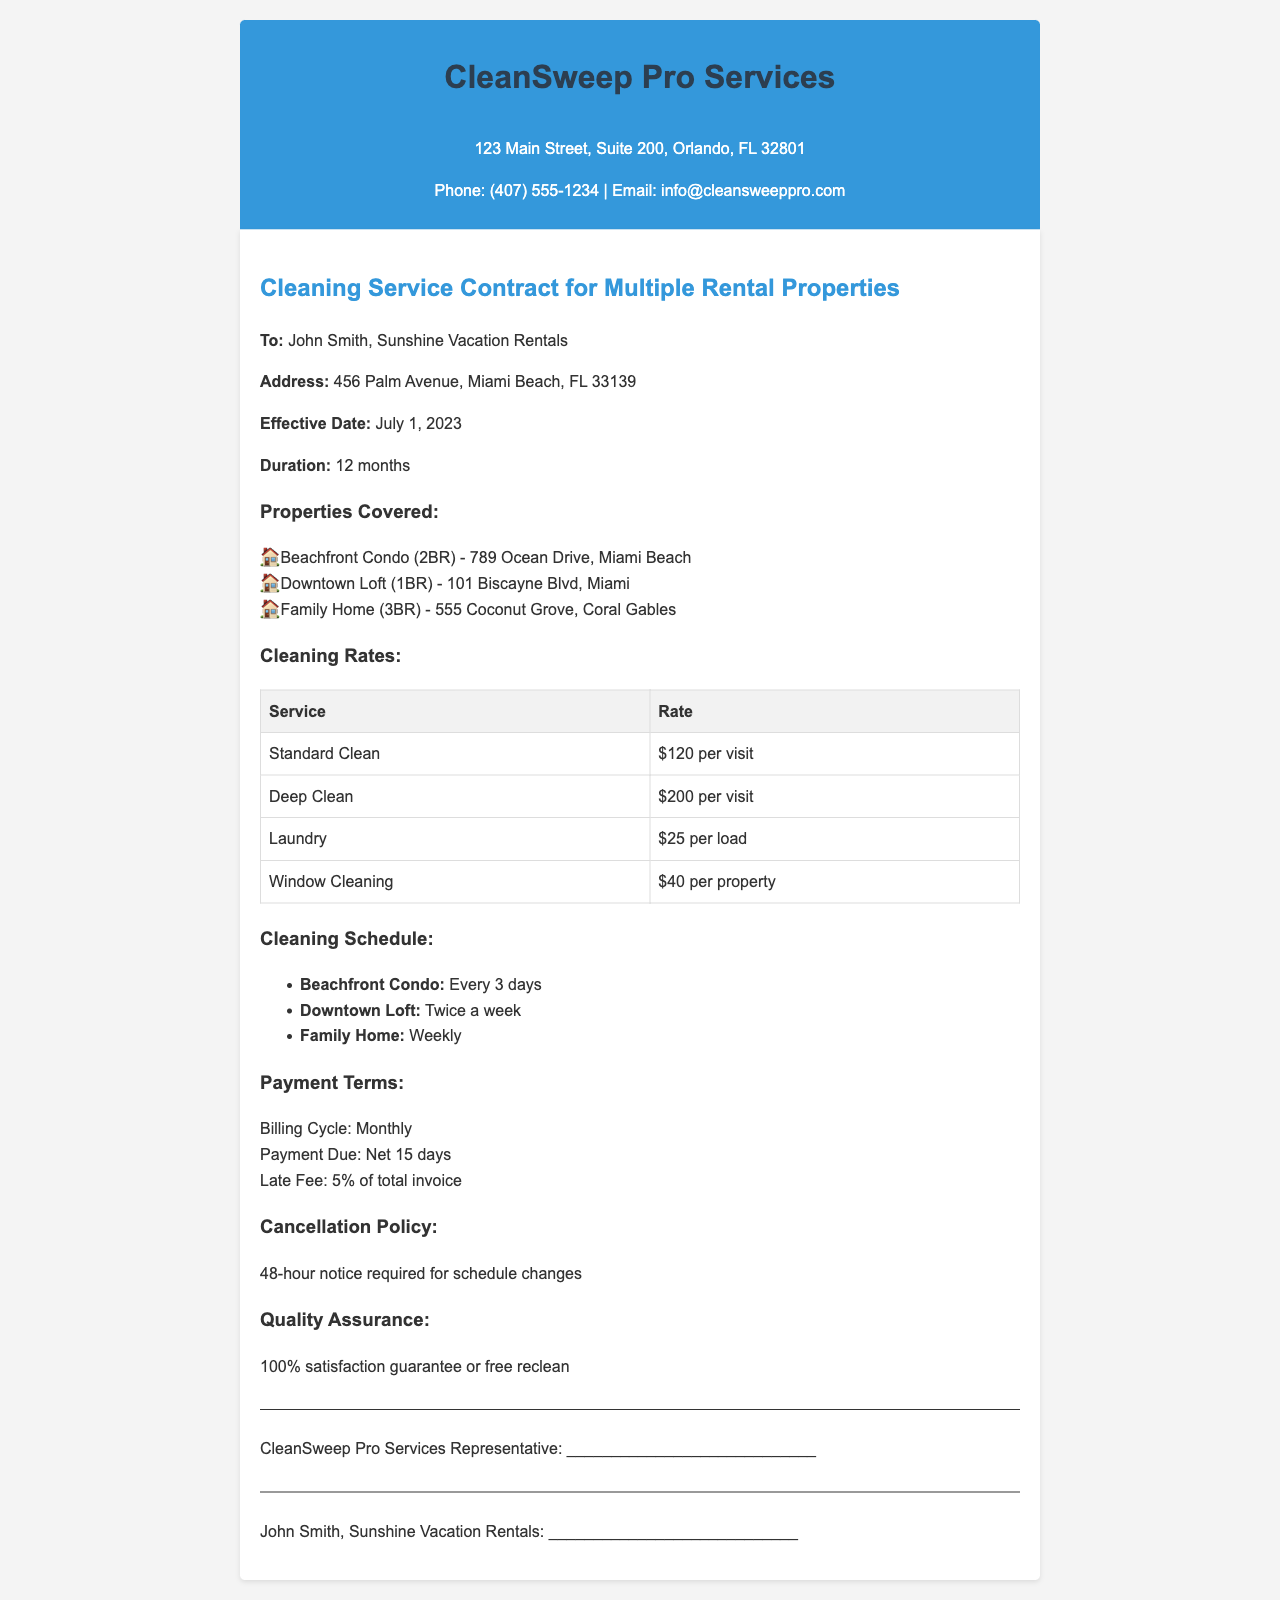what is the name of the cleaning service? The cleaning service is called CleanSweep Pro Services.
Answer: CleanSweep Pro Services who is the contract addressed to? The contract is addressed to John Smith.
Answer: John Smith what is the effective date of the contract? The effective date is specified in the document as July 1, 2023.
Answer: July 1, 2023 how often is the Beachfront Condo cleaned? The cleaning frequency for the Beachfront Condo is set at every 3 days.
Answer: Every 3 days what is the rate for a Deep Clean? The rate for a Deep Clean service is listed as $200 per visit.
Answer: $200 per visit what is the billing cycle for payments? The document states that the billing cycle is monthly.
Answer: Monthly how much is the late fee for overdue payments? The late fee for overdue payments is specified as 5% of the total invoice.
Answer: 5% what must be provided for schedule changes? The document requires that a 48-hour notice be given for schedule changes.
Answer: 48-hour notice what guarantee is provided by CleanSweep Pro Services? The company offers a 100% satisfaction guarantee or free reclean.
Answer: 100% satisfaction guarantee or free reclean 